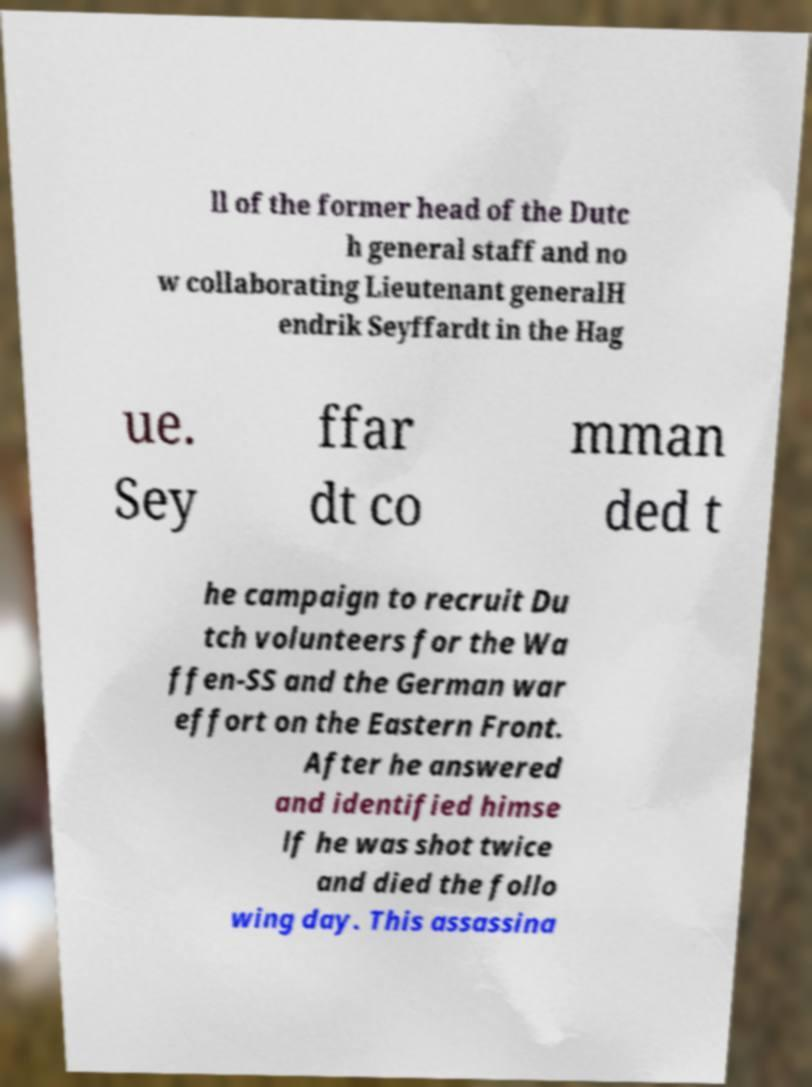Can you accurately transcribe the text from the provided image for me? ll of the former head of the Dutc h general staff and no w collaborating Lieutenant generalH endrik Seyffardt in the Hag ue. Sey ffar dt co mman ded t he campaign to recruit Du tch volunteers for the Wa ffen-SS and the German war effort on the Eastern Front. After he answered and identified himse lf he was shot twice and died the follo wing day. This assassina 